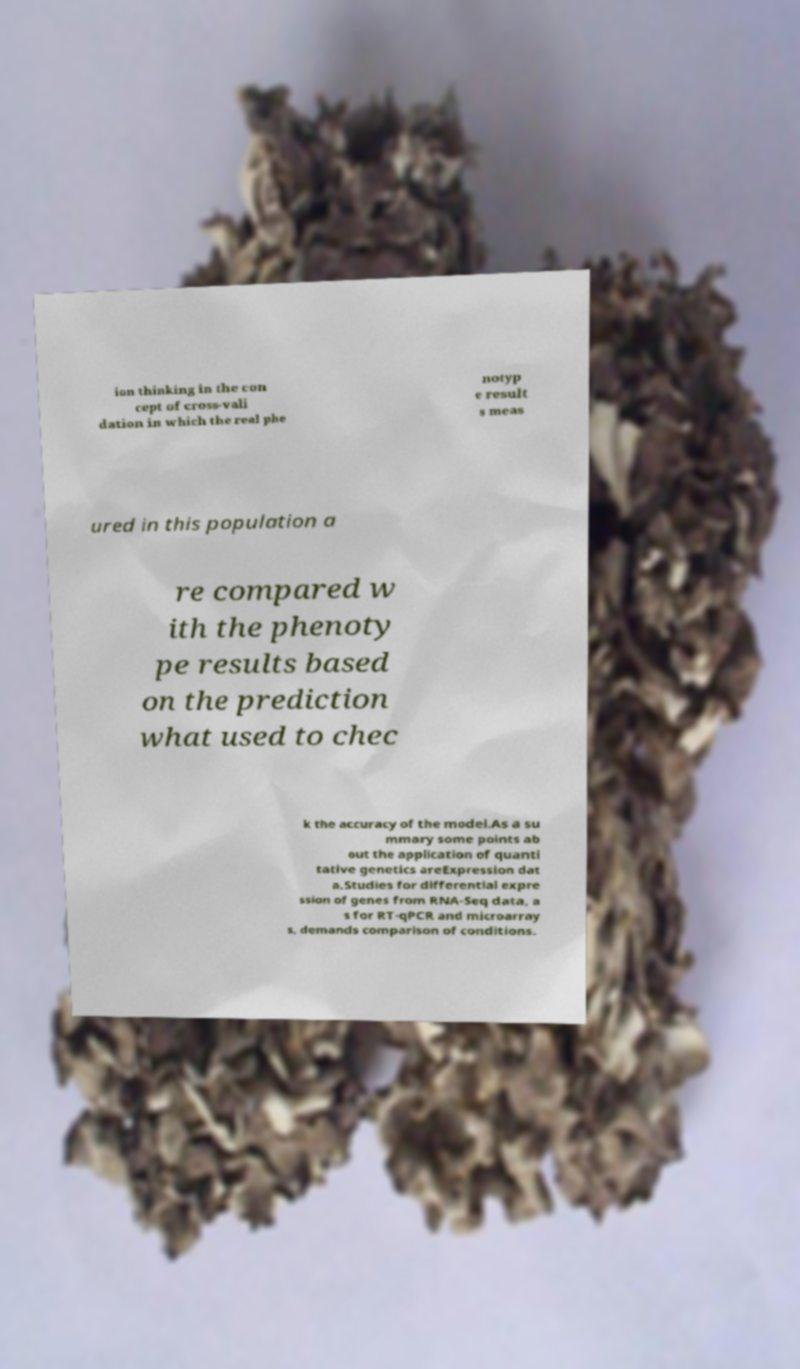There's text embedded in this image that I need extracted. Can you transcribe it verbatim? ion thinking in the con cept of cross-vali dation in which the real phe notyp e result s meas ured in this population a re compared w ith the phenoty pe results based on the prediction what used to chec k the accuracy of the model.As a su mmary some points ab out the application of quanti tative genetics areExpression dat a.Studies for differential expre ssion of genes from RNA-Seq data, a s for RT-qPCR and microarray s, demands comparison of conditions. 